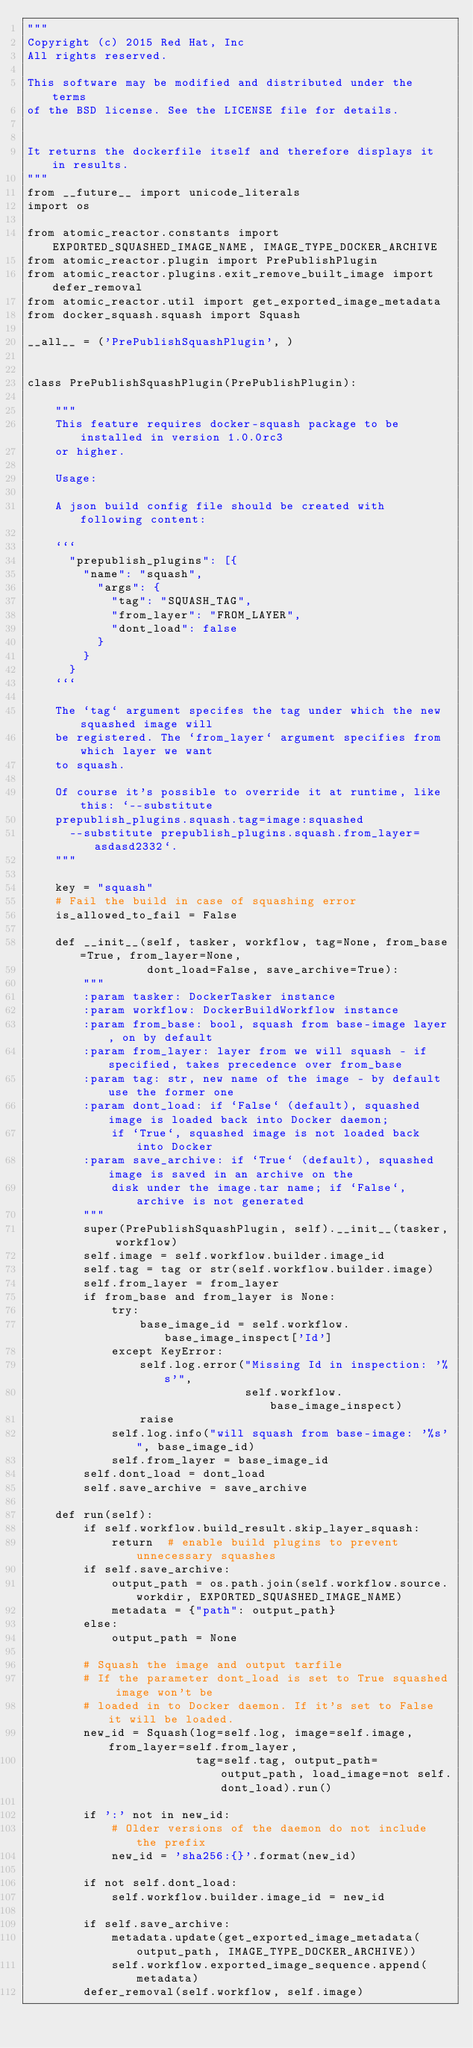<code> <loc_0><loc_0><loc_500><loc_500><_Python_>"""
Copyright (c) 2015 Red Hat, Inc
All rights reserved.

This software may be modified and distributed under the terms
of the BSD license. See the LICENSE file for details.


It returns the dockerfile itself and therefore displays it in results.
"""
from __future__ import unicode_literals
import os

from atomic_reactor.constants import EXPORTED_SQUASHED_IMAGE_NAME, IMAGE_TYPE_DOCKER_ARCHIVE
from atomic_reactor.plugin import PrePublishPlugin
from atomic_reactor.plugins.exit_remove_built_image import defer_removal
from atomic_reactor.util import get_exported_image_metadata
from docker_squash.squash import Squash

__all__ = ('PrePublishSquashPlugin', )


class PrePublishSquashPlugin(PrePublishPlugin):

    """
    This feature requires docker-squash package to be installed in version 1.0.0rc3
    or higher.

    Usage:

    A json build config file should be created with following content:

    ```
      "prepublish_plugins": [{
        "name": "squash",
          "args": {
            "tag": "SQUASH_TAG",
            "from_layer": "FROM_LAYER",
            "dont_load": false
          }
        }
      }
    ```

    The `tag` argument specifes the tag under which the new squashed image will
    be registered. The `from_layer` argument specifies from which layer we want
    to squash.

    Of course it's possible to override it at runtime, like this: `--substitute
    prepublish_plugins.squash.tag=image:squashed
      --substitute prepublish_plugins.squash.from_layer=asdasd2332`.
    """

    key = "squash"
    # Fail the build in case of squashing error
    is_allowed_to_fail = False

    def __init__(self, tasker, workflow, tag=None, from_base=True, from_layer=None,
                 dont_load=False, save_archive=True):
        """
        :param tasker: DockerTasker instance
        :param workflow: DockerBuildWorkflow instance
        :param from_base: bool, squash from base-image layer, on by default
        :param from_layer: layer from we will squash - if specified, takes precedence over from_base
        :param tag: str, new name of the image - by default use the former one
        :param dont_load: if `False` (default), squashed image is loaded back into Docker daemon;
            if `True`, squashed image is not loaded back into Docker
        :param save_archive: if `True` (default), squashed image is saved in an archive on the
            disk under the image.tar name; if `False`, archive is not generated
        """
        super(PrePublishSquashPlugin, self).__init__(tasker, workflow)
        self.image = self.workflow.builder.image_id
        self.tag = tag or str(self.workflow.builder.image)
        self.from_layer = from_layer
        if from_base and from_layer is None:
            try:
                base_image_id = self.workflow.base_image_inspect['Id']
            except KeyError:
                self.log.error("Missing Id in inspection: '%s'",
                               self.workflow.base_image_inspect)
                raise
            self.log.info("will squash from base-image: '%s'", base_image_id)
            self.from_layer = base_image_id
        self.dont_load = dont_load
        self.save_archive = save_archive

    def run(self):
        if self.workflow.build_result.skip_layer_squash:
            return  # enable build plugins to prevent unnecessary squashes
        if self.save_archive:
            output_path = os.path.join(self.workflow.source.workdir, EXPORTED_SQUASHED_IMAGE_NAME)
            metadata = {"path": output_path}
        else:
            output_path = None

        # Squash the image and output tarfile
        # If the parameter dont_load is set to True squashed image won't be
        # loaded in to Docker daemon. If it's set to False it will be loaded.
        new_id = Squash(log=self.log, image=self.image, from_layer=self.from_layer,
                        tag=self.tag, output_path=output_path, load_image=not self.dont_load).run()

        if ':' not in new_id:
            # Older versions of the daemon do not include the prefix
            new_id = 'sha256:{}'.format(new_id)

        if not self.dont_load:
            self.workflow.builder.image_id = new_id

        if self.save_archive:
            metadata.update(get_exported_image_metadata(output_path, IMAGE_TYPE_DOCKER_ARCHIVE))
            self.workflow.exported_image_sequence.append(metadata)
        defer_removal(self.workflow, self.image)
</code> 